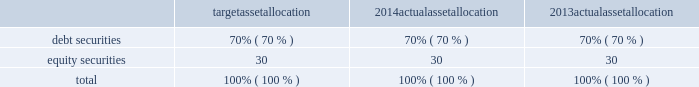Republic services , inc .
Notes to consolidated financial statements 2014 ( continued ) we determine the discount rate used in the measurement of our obligations based on a model that matches the timing and amount of expected benefit payments to maturities of high quality bonds priced as of the pension plan measurement date .
When that timing does not correspond to a published high-quality bond rate , our model uses an expected yield curve to determine an appropriate current discount rate .
The yields on the bonds are used to derive a discount rate for the liability .
The term of our obligation , based on the expected retirement dates of our workforce , is approximately ten years .
In developing our expected rate of return assumption , we have evaluated the actual historical performance and long-term return projections of the plan assets , which give consideration to the asset mix and the anticipated timing of the pension plan outflows .
We employ a total return investment approach whereby a mix of equity and fixed income investments are used to maximize the long-term return of plan assets for what we consider a prudent level of risk .
The intent of this strategy is to minimize plan expenses by outperforming plan liabilities over the long run .
Risk tolerance is established through careful consideration of plan liabilities , plan funded status and our financial condition .
The investment portfolio contains a diversified blend of equity and fixed income investments .
Furthermore , equity investments are diversified across u.s .
And non-u.s .
Stocks as well as growth , value , and small and large capitalizations .
Derivatives may be used to gain market exposure in an efficient and timely manner ; however , derivatives may not be used to leverage the portfolio beyond the market value of the underlying investments .
Investment risk is measured and monitored on an ongoing basis through annual liability measurements , periodic asset and liability studies , and quarterly investment portfolio reviews .
The table summarizes our target asset allocation for 2014 and actual asset allocation as of december 31 , 2014 and 2013 for our defined benefit pension plan : target allocation actual allocation actual allocation .
For 2015 , the investment strategy for pension plan assets is to maintain a broadly diversified portfolio designed to achieve our target of an average long-term rate of return of 6.35% ( 6.35 % ) .
While we believe we can achieve a long- term average return of 6.35% ( 6.35 % ) , we cannot be certain that the portfolio will perform to our expectations .
Assets are strategically allocated among debt and equity portfolios to achieve a diversification level that reduces fluctuations in investment returns .
Asset allocation target ranges and strategies are reviewed periodically with the assistance of an independent external consulting firm. .
Based on the 2014 actualassetallocation what was the debt to equity ratio? 
Rationale: the debt to equity ratio is the ratio of the debt to equity in terms of the financing of the company
Computations: (70 / 30)
Answer: 2.33333. 